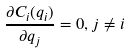Convert formula to latex. <formula><loc_0><loc_0><loc_500><loc_500>\frac { \partial C _ { i } ( q _ { i } ) } { \partial q _ { j } } = 0 , j \ne i</formula> 